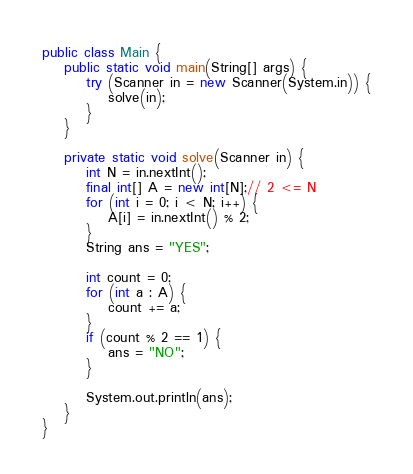Convert code to text. <code><loc_0><loc_0><loc_500><loc_500><_Java_>public class Main {
    public static void main(String[] args) {
        try (Scanner in = new Scanner(System.in)) {
            solve(in);
        }
    }

    private static void solve(Scanner in) {
        int N = in.nextInt();
        final int[] A = new int[N];// 2 <= N
        for (int i = 0; i < N; i++) {
            A[i] = in.nextInt() % 2;
        }
        String ans = "YES";

        int count = 0;
        for (int a : A) {
            count += a;
        }
        if (count % 2 == 1) {
            ans = "NO";
        }

        System.out.println(ans);
    }
}</code> 